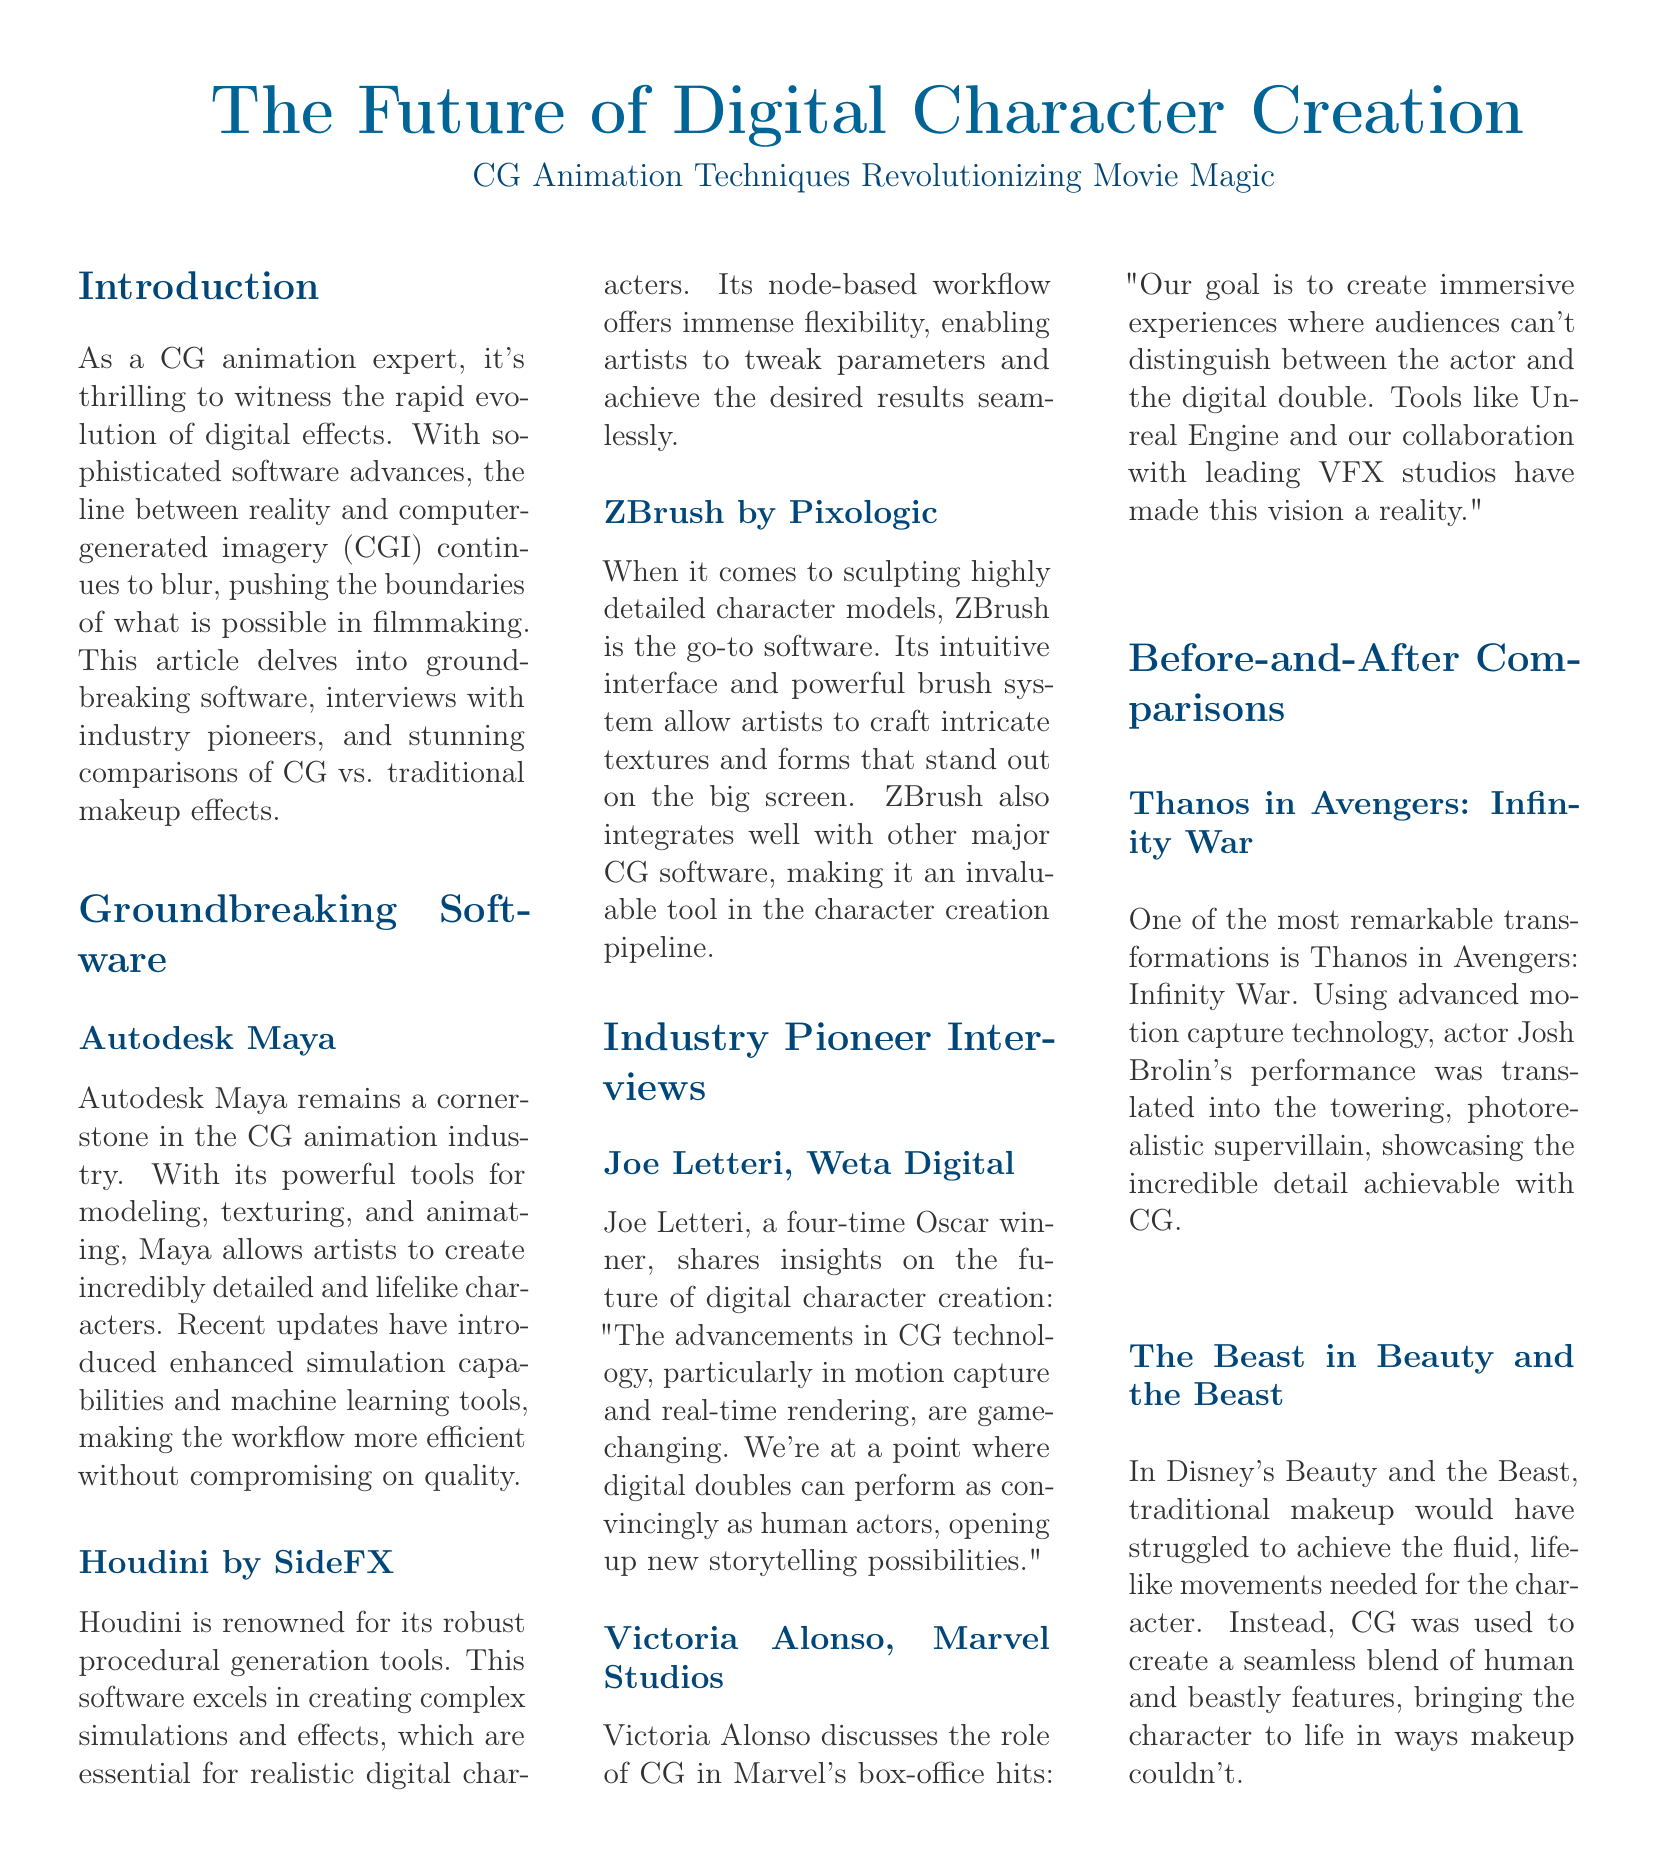what software is a cornerstone in CG animation? The document mentions that Autodesk Maya is a cornerstone in the CG animation industry.
Answer: Autodesk Maya who is a four-time Oscar winner interviewed in the document? Joe Letteri is cited as a four-time Oscar winner in the interview section.
Answer: Joe Letteri what character's transformation is highlighted in the before-and-after comparisons? Thanos in Avengers: Infinity War is highlighted for his transformation.
Answer: Thanos what is the role of CG in Marvel Studios films according to Victoria Alonso? Victoria Alonso discusses that the goal is to create immersive experiences where audiences can't distinguish between the actor and the digital double.
Answer: Immersive experiences which software is known for its sculpting capabilities? The document states that ZBrush is the go-to software for sculpting highly detailed character models.
Answer: ZBrush what technology is noted as game-changing for digital character creation? The advancements in motion capture and real-time rendering are noted as game-changing in the document.
Answer: Motion capture and real-time rendering how does Houdini excel in CG animation according to the document? The document states that Houdini excels in creating complex simulations and effects with its robust procedural generation tools.
Answer: Complex simulations and effects what was necessary for the character The Beast in Beauty and the Beast? The document indicates that traditional makeup would have struggled to achieve the fluid, lifelike movements needed for the character.
Answer: CG was necessary 